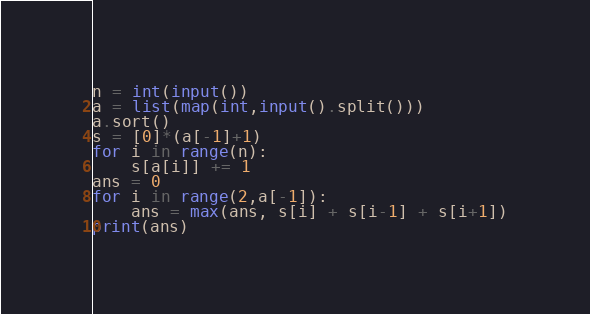<code> <loc_0><loc_0><loc_500><loc_500><_Python_>n = int(input())
a = list(map(int,input().split()))
a.sort()
s = [0]*(a[-1]+1)
for i in range(n):
    s[a[i]] += 1
ans = 0
for i in range(2,a[-1]):
    ans = max(ans, s[i] + s[i-1] + s[i+1])
print(ans)</code> 